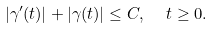<formula> <loc_0><loc_0><loc_500><loc_500>| \gamma ^ { \prime } ( t ) | + | \gamma ( t ) | \leq C , \ \ t \geq 0 .</formula> 